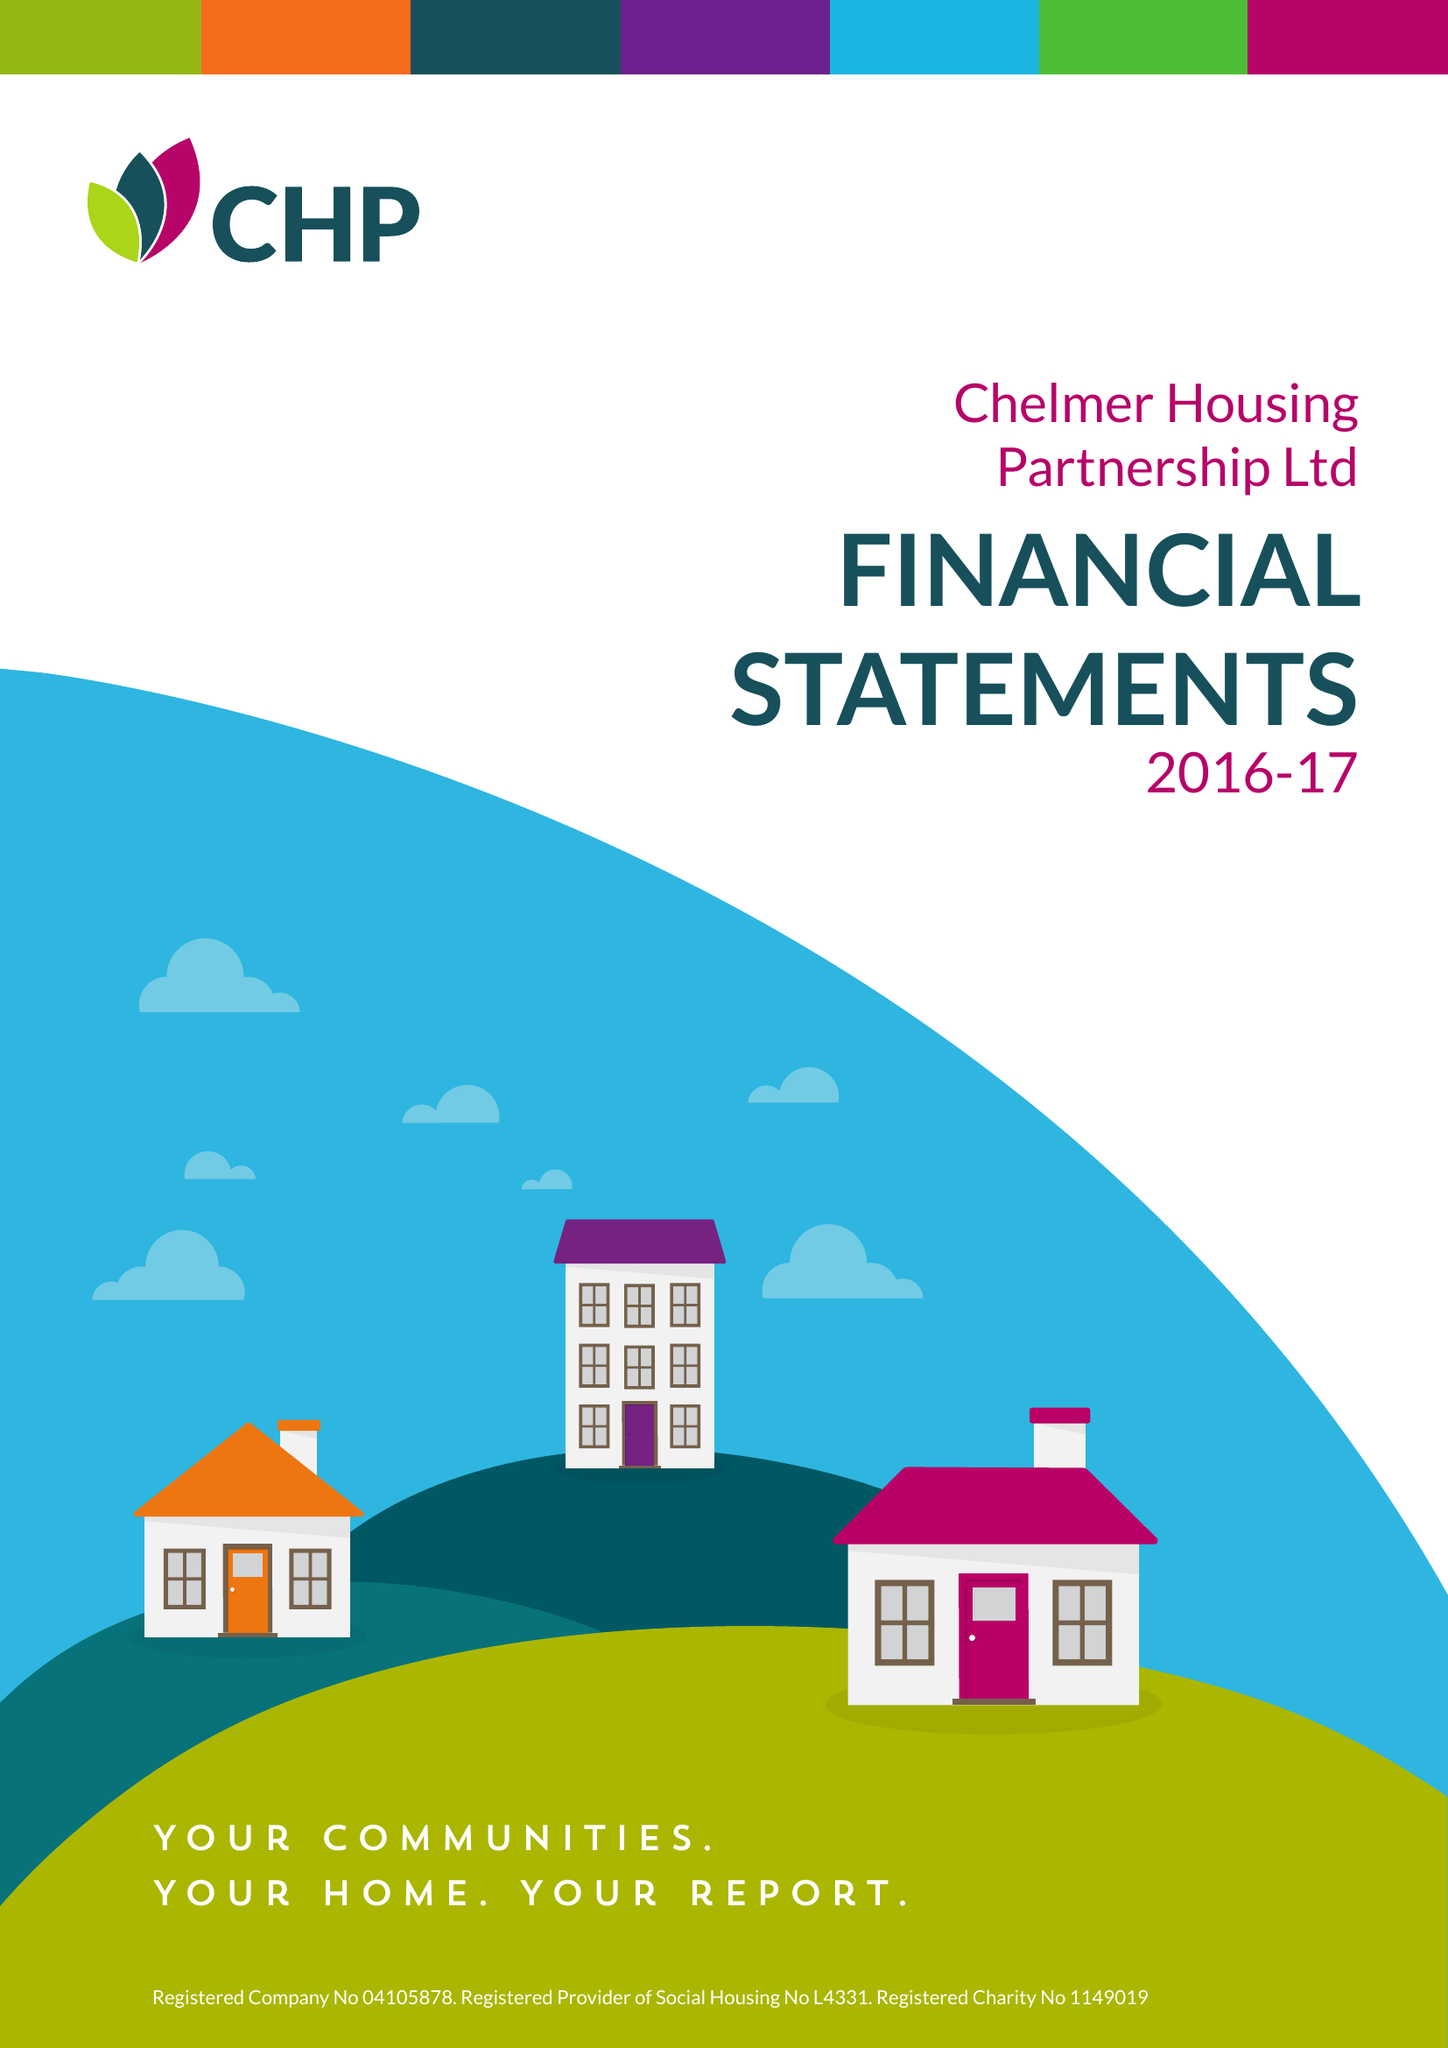What is the value for the address__postcode?
Answer the question using a single word or phrase. CM2 5LB 